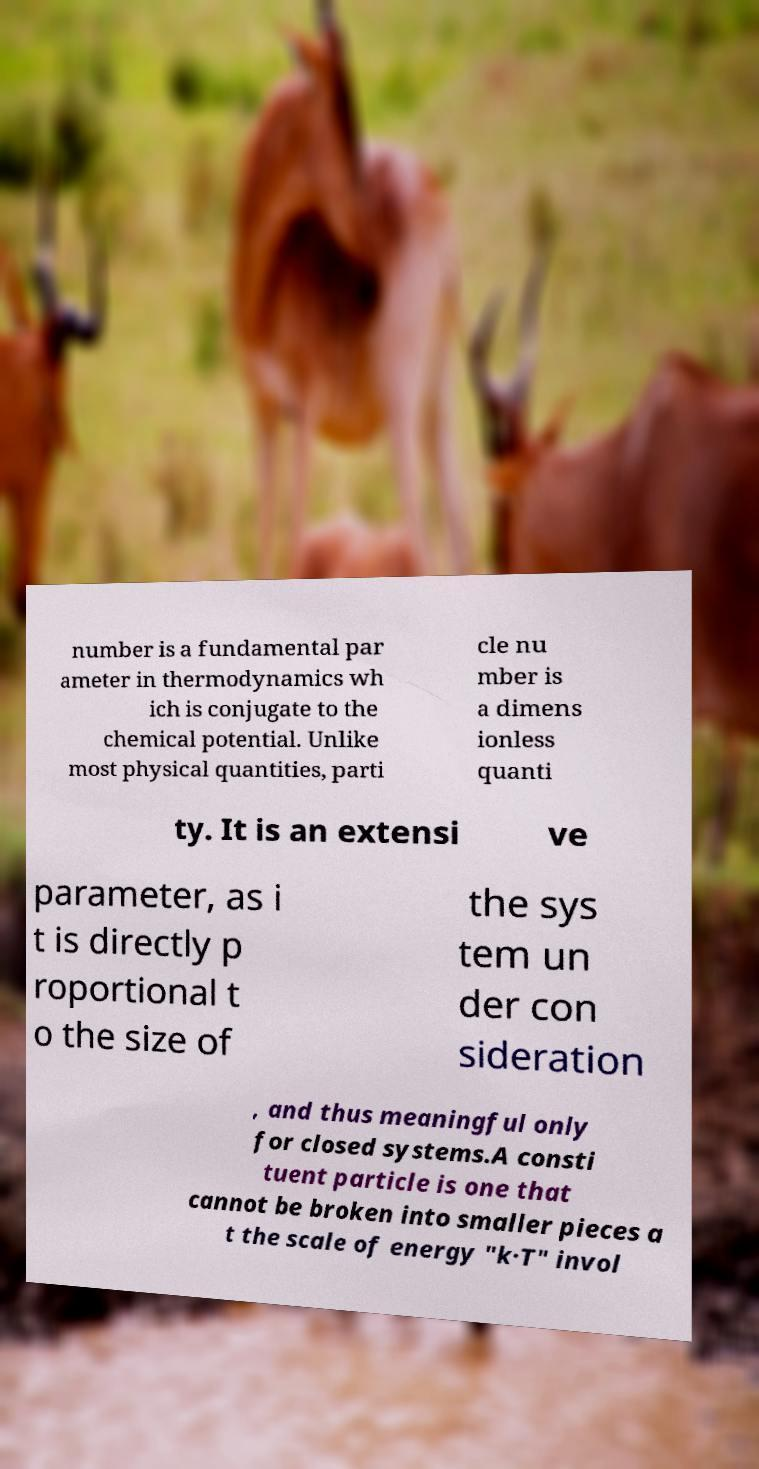What messages or text are displayed in this image? I need them in a readable, typed format. number is a fundamental par ameter in thermodynamics wh ich is conjugate to the chemical potential. Unlike most physical quantities, parti cle nu mber is a dimens ionless quanti ty. It is an extensi ve parameter, as i t is directly p roportional t o the size of the sys tem un der con sideration , and thus meaningful only for closed systems.A consti tuent particle is one that cannot be broken into smaller pieces a t the scale of energy "k·T" invol 